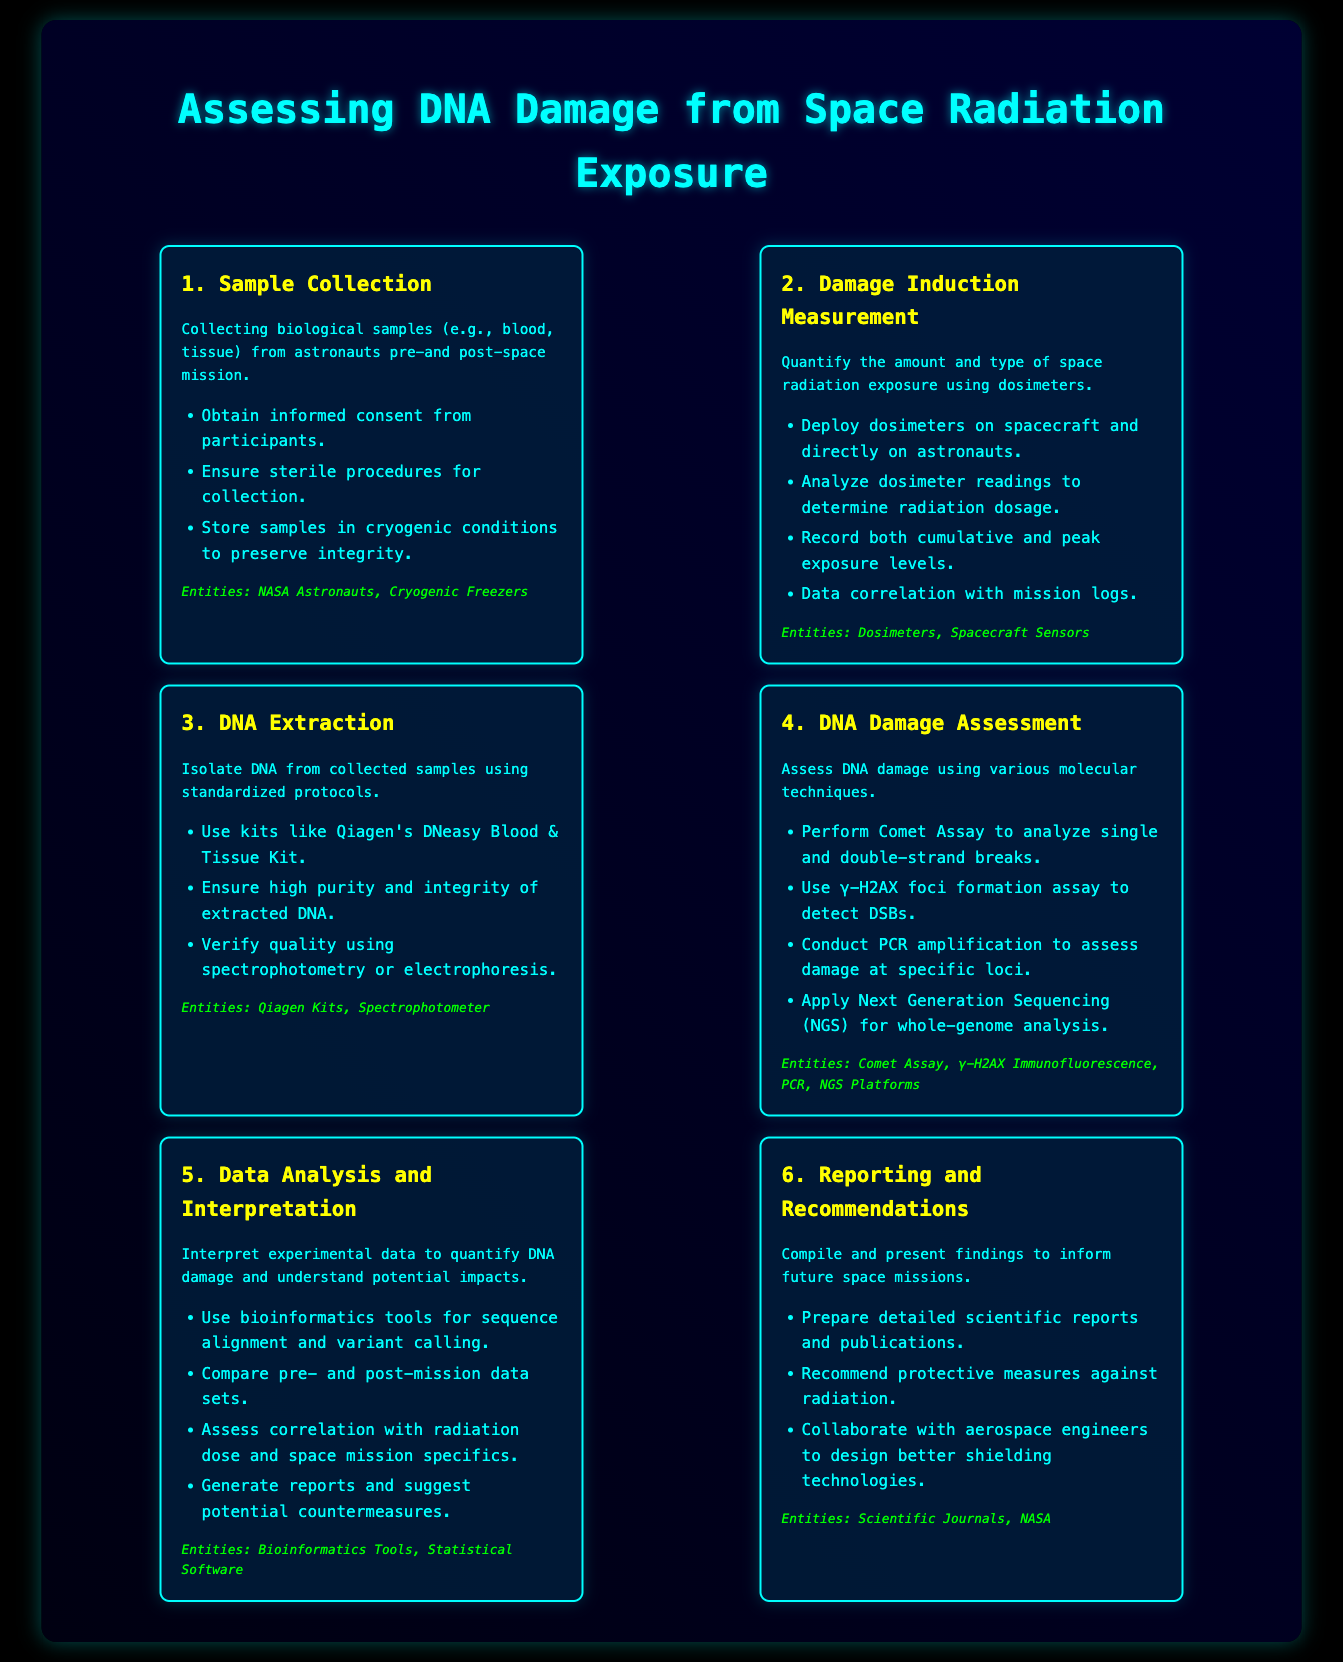What is the first step in assessing DNA damage? The first step in the process, as indicated in the infographic, is "Sample Collection."
Answer: Sample Collection What type of samples are collected? The document specifies that biological samples such as blood and tissue are collected from astronauts.
Answer: Blood, tissue Which kit is mentioned for DNA extraction? The infographic refers to "Qiagen's DNeasy Blood & Tissue Kit" as the tool used for isolating DNA.
Answer: Qiagen's DNeasy Blood & Tissue Kit What molecular technique is used to assess double-strand breaks? The document mentions the "γ-H2AX foci formation assay" as a technique for detecting double-strand breaks.
Answer: γ-H2AX foci formation assay What is the last step of the process? According to the infographic, the last step of the assessing process is "Reporting and Recommendations."
Answer: Reporting and Recommendations How are data sets compared in the analysis phase? The process states that pre- and post-mission data sets are compared to evaluate DNA damage.
Answer: Compare pre- and post-mission data sets What is the purpose of deploying dosimeters? The document states that dosimeters are deployed to quantify the amount and type of space radiation exposure.
Answer: Quantify radiation exposure Which entities are involved in the final reporting step? The infographic lists "Scientific Journals" and "NASA" as the entities involved in the findings compilation and recommendations.
Answer: Scientific Journals, NASA What does the Comet Assay analyze? The Comet Assay is mentioned in the infographic as an analysis method for single and double-strand breaks in DNA.
Answer: Single and double-strand breaks 